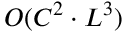<formula> <loc_0><loc_0><loc_500><loc_500>O ( C ^ { 2 } \cdot L ^ { 3 } )</formula> 